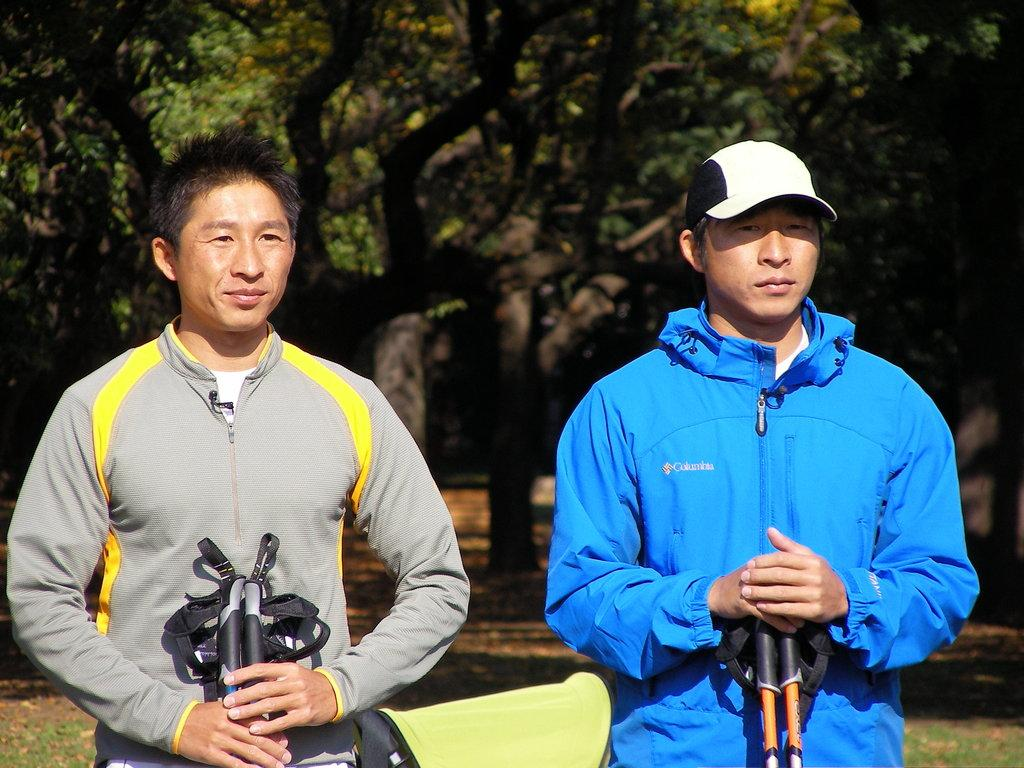What is the main subject of the image? The main subject of the image is men standing. Where are the men standing in the image? The men are standing on the ground. What can be seen in the background of the image? There are trees in the background of the image. What is present on the ground in the background? Shredded leaves are present on the ground in the background. What type of cherry is being processed by the men in the image? There is no cherry or processing activity present in the image; it features men standing on the ground with trees in the background. 